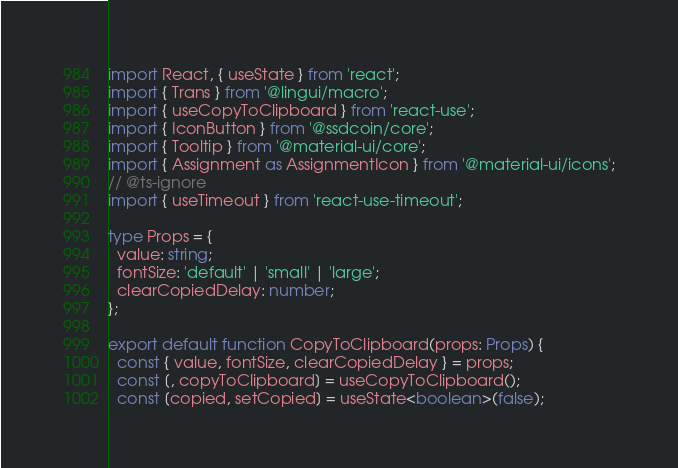<code> <loc_0><loc_0><loc_500><loc_500><_TypeScript_>import React, { useState } from 'react';
import { Trans } from '@lingui/macro';
import { useCopyToClipboard } from 'react-use';
import { IconButton } from '@ssdcoin/core';
import { Tooltip } from '@material-ui/core';
import { Assignment as AssignmentIcon } from '@material-ui/icons';
// @ts-ignore
import { useTimeout } from 'react-use-timeout';

type Props = {
  value: string;
  fontSize: 'default' | 'small' | 'large';
  clearCopiedDelay: number;
};

export default function CopyToClipboard(props: Props) {
  const { value, fontSize, clearCopiedDelay } = props;
  const [, copyToClipboard] = useCopyToClipboard();
  const [copied, setCopied] = useState<boolean>(false);</code> 